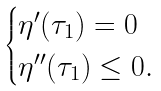Convert formula to latex. <formula><loc_0><loc_0><loc_500><loc_500>\begin{cases} \eta ^ { \prime } ( \tau _ { 1 } ) = 0 \\ \eta ^ { \prime \prime } ( \tau _ { 1 } ) \leq 0 . \end{cases}</formula> 